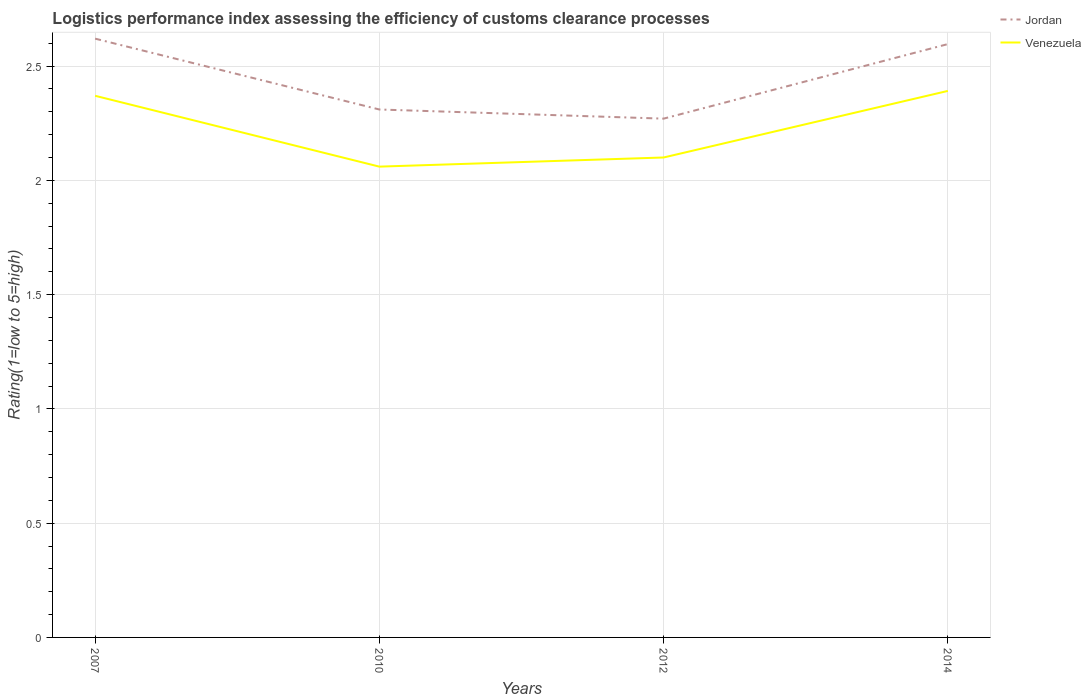Is the number of lines equal to the number of legend labels?
Your answer should be very brief. Yes. Across all years, what is the maximum Logistic performance index in Venezuela?
Ensure brevity in your answer.  2.06. In which year was the Logistic performance index in Venezuela maximum?
Your response must be concise. 2010. What is the total Logistic performance index in Jordan in the graph?
Your response must be concise. 0.31. What is the difference between the highest and the second highest Logistic performance index in Jordan?
Provide a succinct answer. 0.35. How many lines are there?
Your answer should be very brief. 2. How many years are there in the graph?
Your answer should be compact. 4. What is the difference between two consecutive major ticks on the Y-axis?
Provide a succinct answer. 0.5. Are the values on the major ticks of Y-axis written in scientific E-notation?
Offer a terse response. No. Does the graph contain any zero values?
Provide a short and direct response. No. What is the title of the graph?
Your answer should be compact. Logistics performance index assessing the efficiency of customs clearance processes. Does "Equatorial Guinea" appear as one of the legend labels in the graph?
Your response must be concise. No. What is the label or title of the X-axis?
Make the answer very short. Years. What is the label or title of the Y-axis?
Your answer should be very brief. Rating(1=low to 5=high). What is the Rating(1=low to 5=high) of Jordan in 2007?
Provide a succinct answer. 2.62. What is the Rating(1=low to 5=high) in Venezuela in 2007?
Provide a short and direct response. 2.37. What is the Rating(1=low to 5=high) of Jordan in 2010?
Your answer should be compact. 2.31. What is the Rating(1=low to 5=high) of Venezuela in 2010?
Offer a very short reply. 2.06. What is the Rating(1=low to 5=high) in Jordan in 2012?
Provide a short and direct response. 2.27. What is the Rating(1=low to 5=high) in Jordan in 2014?
Ensure brevity in your answer.  2.6. What is the Rating(1=low to 5=high) in Venezuela in 2014?
Offer a terse response. 2.39. Across all years, what is the maximum Rating(1=low to 5=high) in Jordan?
Your answer should be very brief. 2.62. Across all years, what is the maximum Rating(1=low to 5=high) in Venezuela?
Make the answer very short. 2.39. Across all years, what is the minimum Rating(1=low to 5=high) of Jordan?
Your response must be concise. 2.27. Across all years, what is the minimum Rating(1=low to 5=high) in Venezuela?
Keep it short and to the point. 2.06. What is the total Rating(1=low to 5=high) in Jordan in the graph?
Your answer should be compact. 9.8. What is the total Rating(1=low to 5=high) of Venezuela in the graph?
Keep it short and to the point. 8.92. What is the difference between the Rating(1=low to 5=high) of Jordan in 2007 and that in 2010?
Give a very brief answer. 0.31. What is the difference between the Rating(1=low to 5=high) of Venezuela in 2007 and that in 2010?
Your answer should be very brief. 0.31. What is the difference between the Rating(1=low to 5=high) of Venezuela in 2007 and that in 2012?
Your answer should be very brief. 0.27. What is the difference between the Rating(1=low to 5=high) of Jordan in 2007 and that in 2014?
Provide a short and direct response. 0.02. What is the difference between the Rating(1=low to 5=high) of Venezuela in 2007 and that in 2014?
Offer a terse response. -0.02. What is the difference between the Rating(1=low to 5=high) of Jordan in 2010 and that in 2012?
Provide a succinct answer. 0.04. What is the difference between the Rating(1=low to 5=high) in Venezuela in 2010 and that in 2012?
Your answer should be very brief. -0.04. What is the difference between the Rating(1=low to 5=high) of Jordan in 2010 and that in 2014?
Offer a terse response. -0.29. What is the difference between the Rating(1=low to 5=high) in Venezuela in 2010 and that in 2014?
Ensure brevity in your answer.  -0.33. What is the difference between the Rating(1=low to 5=high) of Jordan in 2012 and that in 2014?
Offer a terse response. -0.33. What is the difference between the Rating(1=low to 5=high) of Venezuela in 2012 and that in 2014?
Your answer should be compact. -0.29. What is the difference between the Rating(1=low to 5=high) of Jordan in 2007 and the Rating(1=low to 5=high) of Venezuela in 2010?
Your answer should be very brief. 0.56. What is the difference between the Rating(1=low to 5=high) in Jordan in 2007 and the Rating(1=low to 5=high) in Venezuela in 2012?
Offer a very short reply. 0.52. What is the difference between the Rating(1=low to 5=high) of Jordan in 2007 and the Rating(1=low to 5=high) of Venezuela in 2014?
Provide a succinct answer. 0.23. What is the difference between the Rating(1=low to 5=high) of Jordan in 2010 and the Rating(1=low to 5=high) of Venezuela in 2012?
Keep it short and to the point. 0.21. What is the difference between the Rating(1=low to 5=high) of Jordan in 2010 and the Rating(1=low to 5=high) of Venezuela in 2014?
Offer a terse response. -0.08. What is the difference between the Rating(1=low to 5=high) of Jordan in 2012 and the Rating(1=low to 5=high) of Venezuela in 2014?
Give a very brief answer. -0.12. What is the average Rating(1=low to 5=high) of Jordan per year?
Keep it short and to the point. 2.45. What is the average Rating(1=low to 5=high) in Venezuela per year?
Keep it short and to the point. 2.23. In the year 2007, what is the difference between the Rating(1=low to 5=high) of Jordan and Rating(1=low to 5=high) of Venezuela?
Ensure brevity in your answer.  0.25. In the year 2010, what is the difference between the Rating(1=low to 5=high) of Jordan and Rating(1=low to 5=high) of Venezuela?
Your answer should be compact. 0.25. In the year 2012, what is the difference between the Rating(1=low to 5=high) in Jordan and Rating(1=low to 5=high) in Venezuela?
Keep it short and to the point. 0.17. In the year 2014, what is the difference between the Rating(1=low to 5=high) of Jordan and Rating(1=low to 5=high) of Venezuela?
Your answer should be very brief. 0.2. What is the ratio of the Rating(1=low to 5=high) in Jordan in 2007 to that in 2010?
Provide a succinct answer. 1.13. What is the ratio of the Rating(1=low to 5=high) in Venezuela in 2007 to that in 2010?
Provide a succinct answer. 1.15. What is the ratio of the Rating(1=low to 5=high) in Jordan in 2007 to that in 2012?
Provide a succinct answer. 1.15. What is the ratio of the Rating(1=low to 5=high) of Venezuela in 2007 to that in 2012?
Your response must be concise. 1.13. What is the ratio of the Rating(1=low to 5=high) of Jordan in 2007 to that in 2014?
Offer a very short reply. 1.01. What is the ratio of the Rating(1=low to 5=high) of Venezuela in 2007 to that in 2014?
Your response must be concise. 0.99. What is the ratio of the Rating(1=low to 5=high) of Jordan in 2010 to that in 2012?
Your answer should be very brief. 1.02. What is the ratio of the Rating(1=low to 5=high) of Jordan in 2010 to that in 2014?
Keep it short and to the point. 0.89. What is the ratio of the Rating(1=low to 5=high) of Venezuela in 2010 to that in 2014?
Keep it short and to the point. 0.86. What is the ratio of the Rating(1=low to 5=high) of Jordan in 2012 to that in 2014?
Keep it short and to the point. 0.87. What is the ratio of the Rating(1=low to 5=high) of Venezuela in 2012 to that in 2014?
Make the answer very short. 0.88. What is the difference between the highest and the second highest Rating(1=low to 5=high) of Jordan?
Your answer should be very brief. 0.02. What is the difference between the highest and the second highest Rating(1=low to 5=high) of Venezuela?
Give a very brief answer. 0.02. What is the difference between the highest and the lowest Rating(1=low to 5=high) of Venezuela?
Your answer should be very brief. 0.33. 